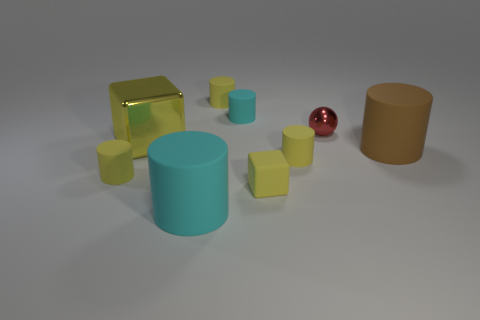If you had to create a story involving these objects, what roles might they play? In a whimsical story, the large yellow metal block could be a treasure chest filled with secrets, the rubber cylinders might be ancient pillars from a long-lost civilization, the cyan matte cylinders could be mystical artifacts with hidden powers, and the shiny red sphere could be the enchanted jewel that is the key to unlocking the chest's mysteries. 